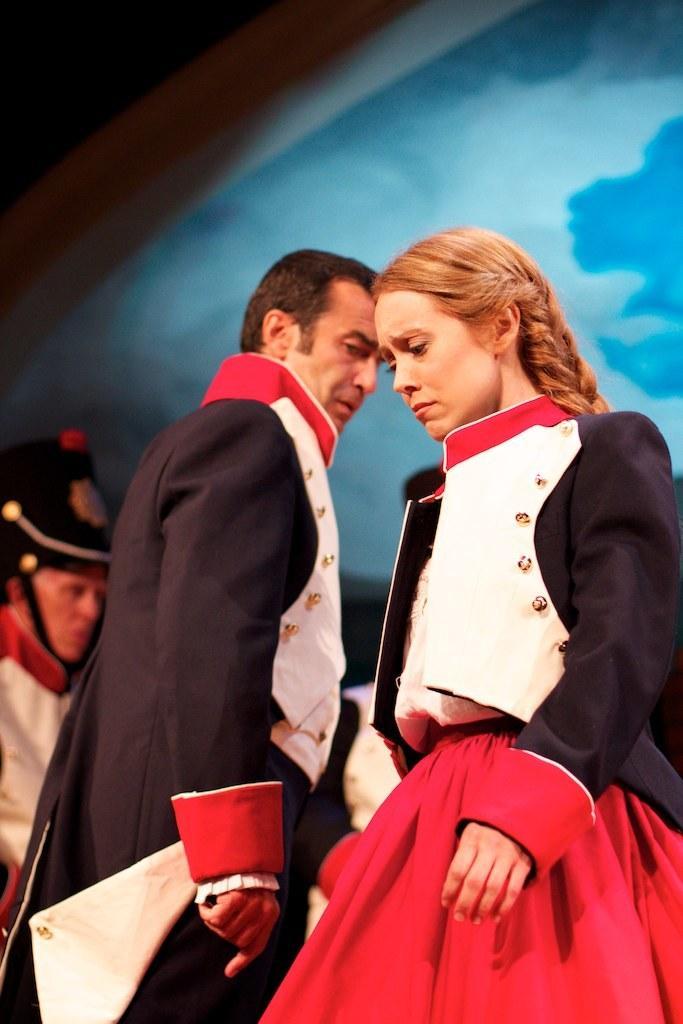Could you give a brief overview of what you see in this image? In this image we can see a man and a woman standing. On the backside we can see a person standing. 